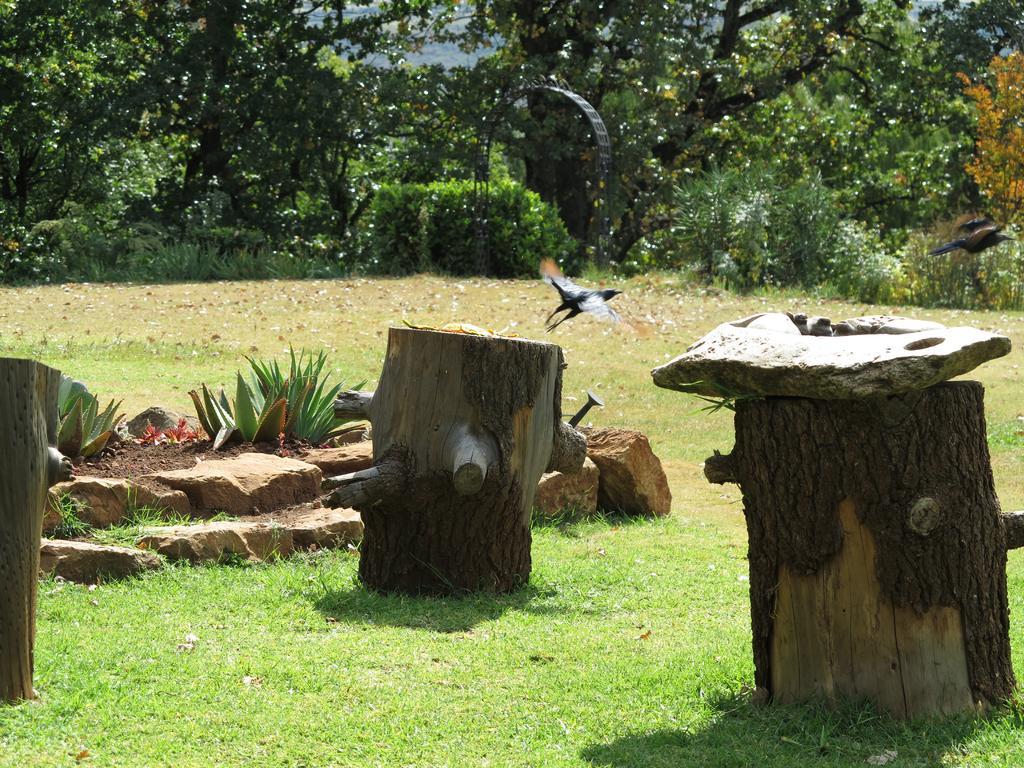Could you give a brief overview of what you see in this image? In this picture there is a black color bird which is flying above the stone. Here we can see three woods. On the left we can see plant. On the bottom we can see grass. On the background we can see many trees. 